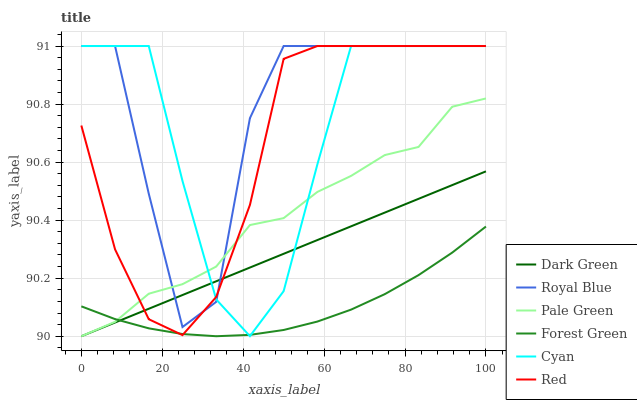Does Forest Green have the minimum area under the curve?
Answer yes or no. Yes. Does Royal Blue have the maximum area under the curve?
Answer yes or no. Yes. Does Pale Green have the minimum area under the curve?
Answer yes or no. No. Does Pale Green have the maximum area under the curve?
Answer yes or no. No. Is Dark Green the smoothest?
Answer yes or no. Yes. Is Royal Blue the roughest?
Answer yes or no. Yes. Is Forest Green the smoothest?
Answer yes or no. No. Is Forest Green the roughest?
Answer yes or no. No. Does Pale Green have the lowest value?
Answer yes or no. Yes. Does Forest Green have the lowest value?
Answer yes or no. No. Does Red have the highest value?
Answer yes or no. Yes. Does Pale Green have the highest value?
Answer yes or no. No. Is Forest Green less than Royal Blue?
Answer yes or no. Yes. Is Royal Blue greater than Forest Green?
Answer yes or no. Yes. Does Pale Green intersect Dark Green?
Answer yes or no. Yes. Is Pale Green less than Dark Green?
Answer yes or no. No. Is Pale Green greater than Dark Green?
Answer yes or no. No. Does Forest Green intersect Royal Blue?
Answer yes or no. No. 